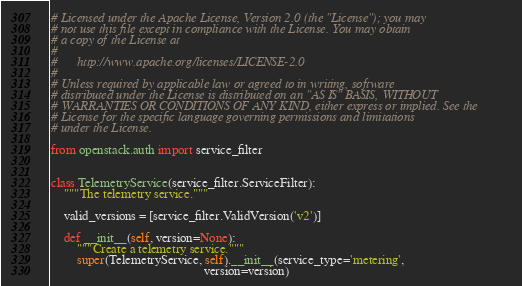<code> <loc_0><loc_0><loc_500><loc_500><_Python_># Licensed under the Apache License, Version 2.0 (the "License"); you may
# not use this file except in compliance with the License. You may obtain
# a copy of the License at
#
#      http://www.apache.org/licenses/LICENSE-2.0
#
# Unless required by applicable law or agreed to in writing, software
# distributed under the License is distributed on an "AS IS" BASIS, WITHOUT
# WARRANTIES OR CONDITIONS OF ANY KIND, either express or implied. See the
# License for the specific language governing permissions and limitations
# under the License.

from openstack.auth import service_filter


class TelemetryService(service_filter.ServiceFilter):
    """The telemetry service."""

    valid_versions = [service_filter.ValidVersion('v2')]

    def __init__(self, version=None):
        """Create a telemetry service."""
        super(TelemetryService, self).__init__(service_type='metering',
                                               version=version)
</code> 